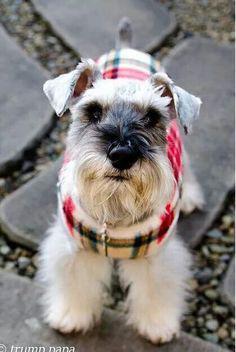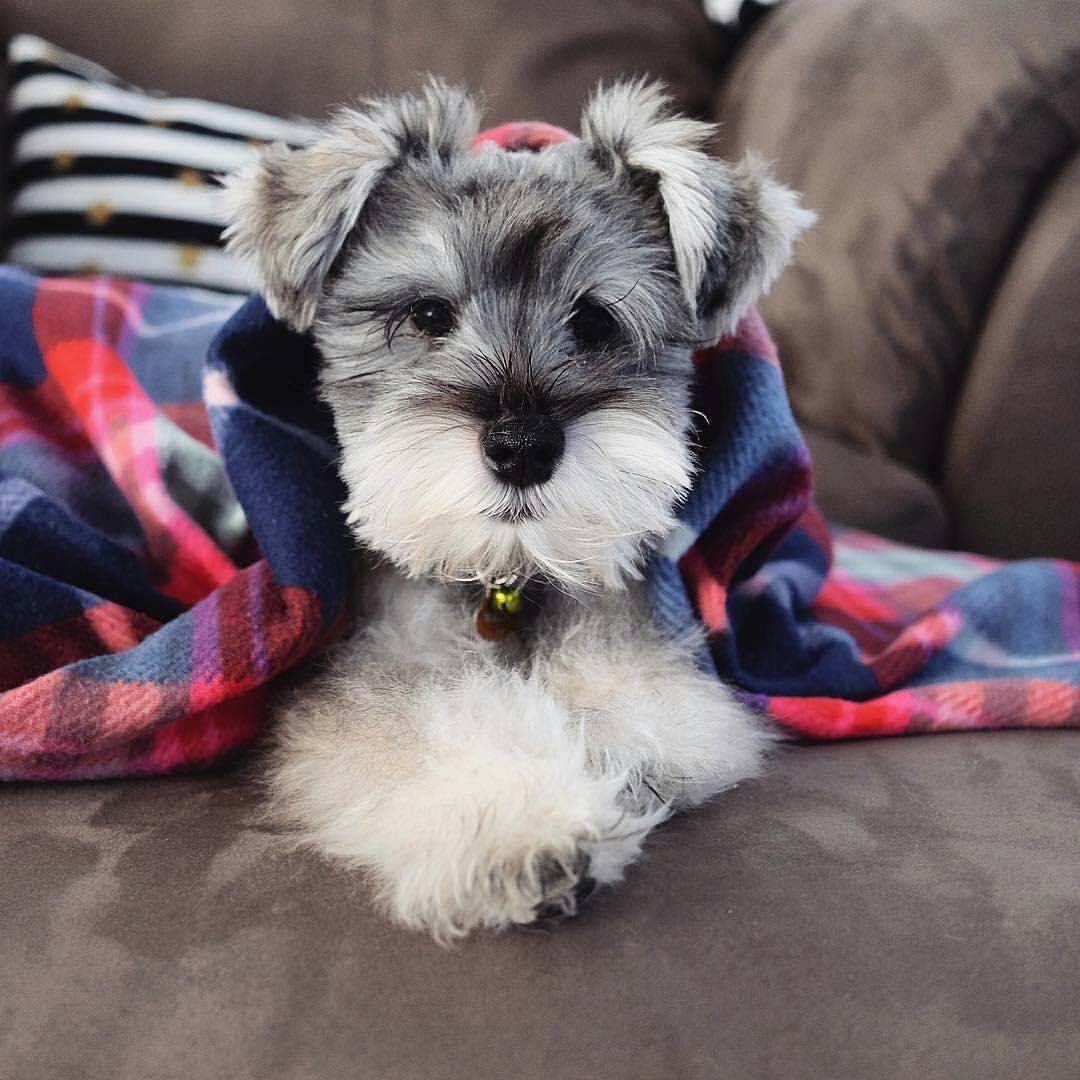The first image is the image on the left, the second image is the image on the right. Examine the images to the left and right. Is the description "An image shows one schnauzer, which is wearing a printed bandana around its neck." accurate? Answer yes or no. No. The first image is the image on the left, the second image is the image on the right. For the images displayed, is the sentence "One of the dogs is sitting in a bag." factually correct? Answer yes or no. No. 